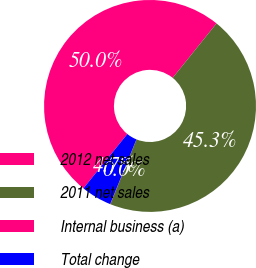Convert chart to OTSL. <chart><loc_0><loc_0><loc_500><loc_500><pie_chart><fcel>2012 net sales<fcel>2011 net sales<fcel>Internal business (a)<fcel>Total change<nl><fcel>49.97%<fcel>45.32%<fcel>0.03%<fcel>4.68%<nl></chart> 